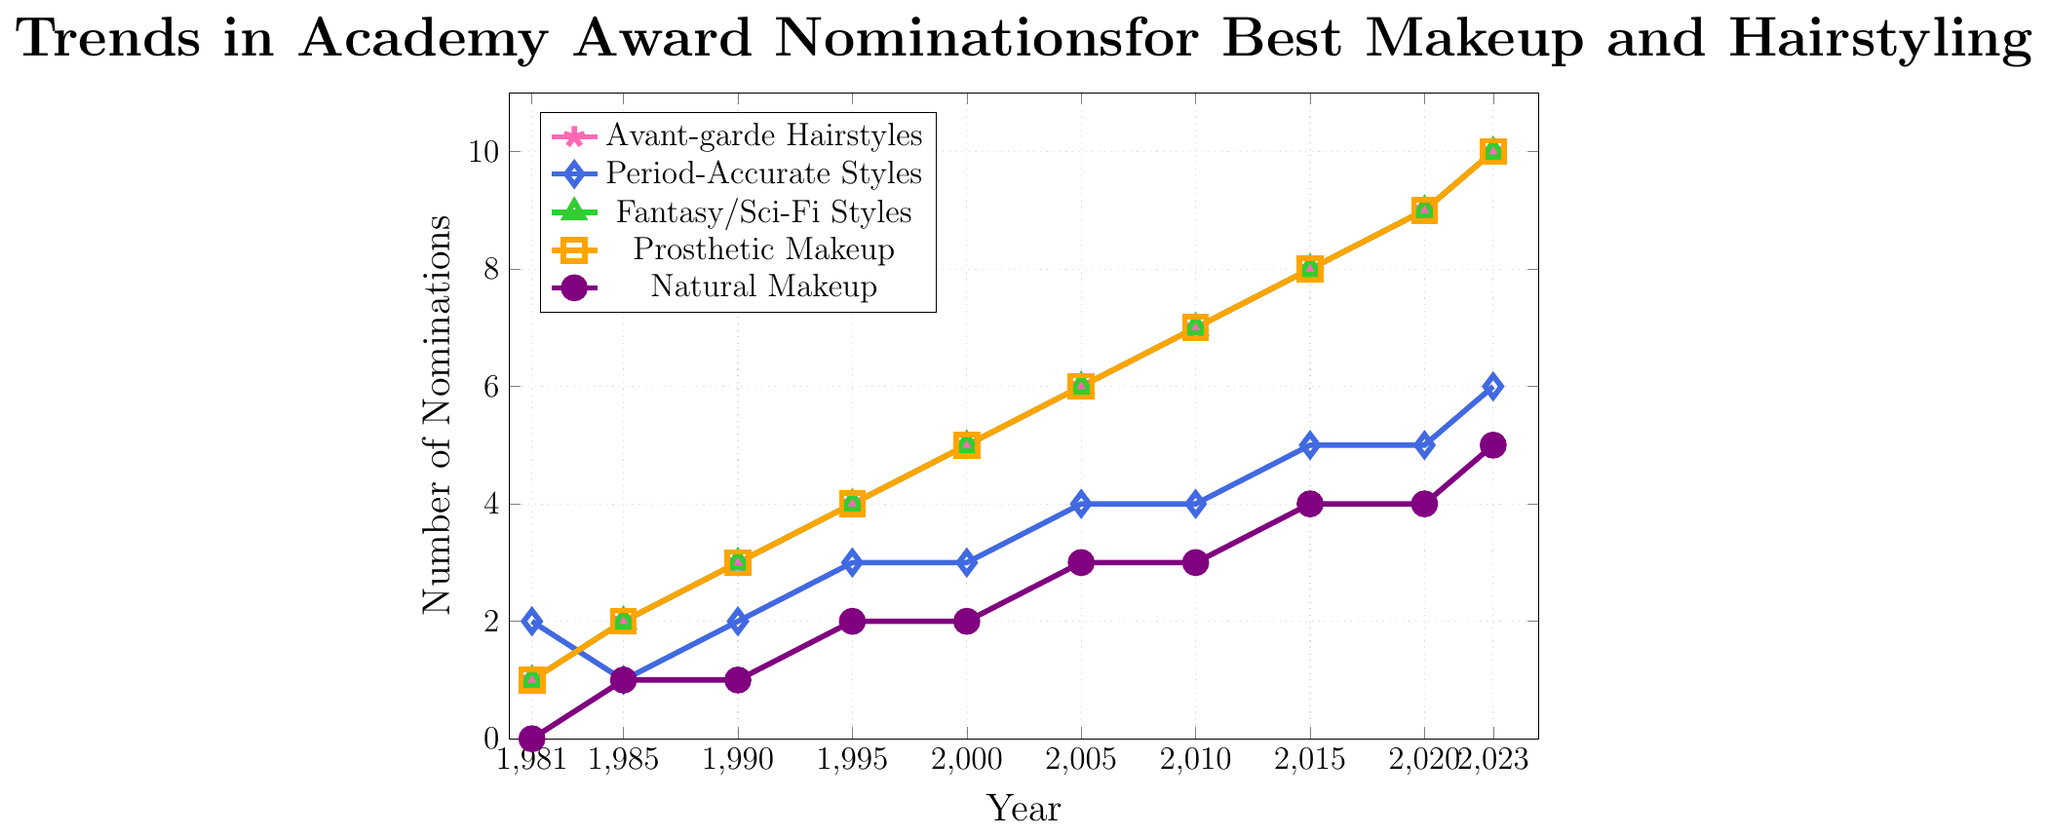What year did Avant-garde Hairstyles and Fantasy/Sci-Fi Styles first have the same number of nominations? Looking at the lines representing Avant-garde Hairstyles and Fantasy/Sci-Fi Styles, they first overlap at year 1981, both with a value of 1 nomination.
Answer: 1981 Which category has shown the most consistent trend in nominations over the years? The line for Natural Makeup shows a steady increase without any sudden jumps or drops, indicating a consistent trend. Other categories such as Avant-garde Hairstyles, Fantasy/Sci-Fi Styles, and Prosthetic Makeup show more rapid increases.
Answer: Natural Makeup By how much did the number of nominations for Prosthetic Makeup increase from 1981 to 2023? The nominations for Prosthetic Makeup in 1981 were 1 and in 2023 were 10. The increase is 10 - 1.
Answer: 9 How many more nominations did Avant-garde Hairstyles receive compared to Period-Accurate Styles in 2023? In 2023, Avant-garde Hairstyles had 10 nominations and Period-Accurate Styles had 6. The difference is 10 - 6.
Answer: 4 Of the five categories, which two had the same number of nominations in 1985? The lines for Avant-garde Hairstyles and Fantasy/Sci-Fi Styles both show 2 nominations in 1985, as do the lines for Prosthetic Makeup and Fantasy/Sci-Fi Styles.
Answer: Avant-garde Hairstyles and Fantasy/Sci-Fi Styles (or) Prosthetic Makeup and Fantasy/Sci-Fi Styles What is the overall trend for nominations in Fantasy/Sci-Fi Styles from 1981 to 2023? The trend line for Fantasy/Sci-Fi Styles shows a steady and linear increase in the number of nominations from 1 in 1981 to 10 in 2023.
Answer: Steady increase Which category had the highest number of nominations in 2020? The lines for Avant-garde Hairstyles, Fantasy/Sci-Fi Styles, and Prosthetic Makeup all show 9 nominations in 2020, the highest among all categories.
Answer: Avant-garde Hairstyles, Fantasy/Sci-Fi Styles, Prosthetic Makeup By how much did the number of nominations for Period-Accurate Styles increase from 2000 to 2023? The nominations for Period-Accurate Styles in 2000 were 3 and in 2023 were 6. The increase is 6 - 3.
Answer: 3 In which year did Natural Makeup first receive more than 2 nominations? The line for Natural Makeup crosses the value of 2 nominations between 2000 and 2005. In 2005, it had exactly 3 nominations.
Answer: 2005 What's the combined number of nominations for Avant-garde Hairstyles and Prosthetic Makeup in 2010? In 2010, Avant-garde Hairstyles had 7 nominations, and Prosthetic Makeup also had 7 nominations. The combined number is 7 + 7.
Answer: 14 